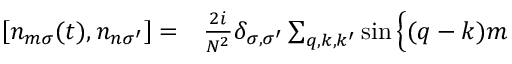<formula> <loc_0><loc_0><loc_500><loc_500>\begin{array} { r l } { \left [ n _ { m \sigma } ( t ) , n _ { n \sigma ^ { \prime } } \right ] = } & \frac { 2 i } { N ^ { 2 } } \delta _ { \sigma , \sigma ^ { \prime } } \sum _ { q , k , k ^ { \prime } } \sin \Big \{ ( q - k ) m } \end{array}</formula> 